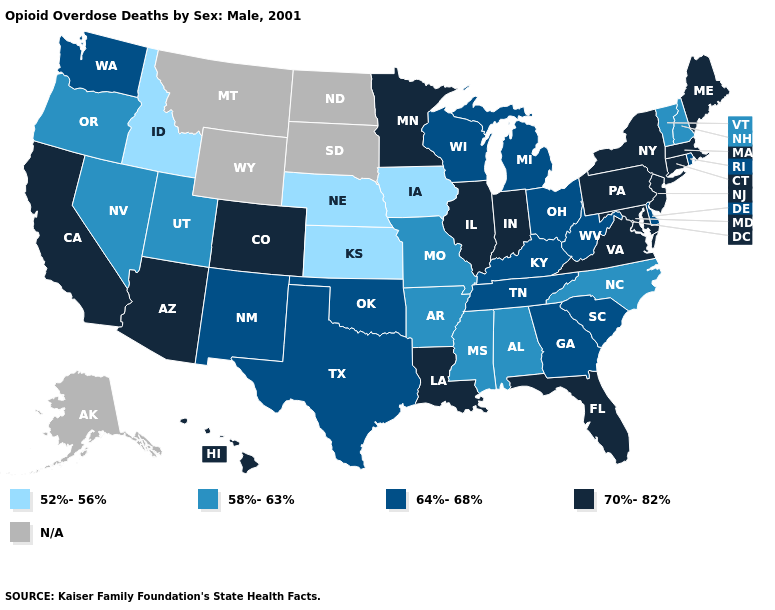What is the lowest value in the USA?
Short answer required. 52%-56%. Name the states that have a value in the range 64%-68%?
Short answer required. Delaware, Georgia, Kentucky, Michigan, New Mexico, Ohio, Oklahoma, Rhode Island, South Carolina, Tennessee, Texas, Washington, West Virginia, Wisconsin. Name the states that have a value in the range 64%-68%?
Concise answer only. Delaware, Georgia, Kentucky, Michigan, New Mexico, Ohio, Oklahoma, Rhode Island, South Carolina, Tennessee, Texas, Washington, West Virginia, Wisconsin. What is the value of Delaware?
Quick response, please. 64%-68%. Among the states that border Nebraska , does Iowa have the lowest value?
Give a very brief answer. Yes. What is the value of Maryland?
Quick response, please. 70%-82%. What is the value of Iowa?
Concise answer only. 52%-56%. Does Florida have the highest value in the South?
Quick response, please. Yes. What is the value of Virginia?
Keep it brief. 70%-82%. Name the states that have a value in the range 52%-56%?
Quick response, please. Idaho, Iowa, Kansas, Nebraska. Name the states that have a value in the range 52%-56%?
Quick response, please. Idaho, Iowa, Kansas, Nebraska. Name the states that have a value in the range 52%-56%?
Keep it brief. Idaho, Iowa, Kansas, Nebraska. Name the states that have a value in the range 58%-63%?
Quick response, please. Alabama, Arkansas, Mississippi, Missouri, Nevada, New Hampshire, North Carolina, Oregon, Utah, Vermont. Which states hav the highest value in the West?
Give a very brief answer. Arizona, California, Colorado, Hawaii. Name the states that have a value in the range N/A?
Concise answer only. Alaska, Montana, North Dakota, South Dakota, Wyoming. 